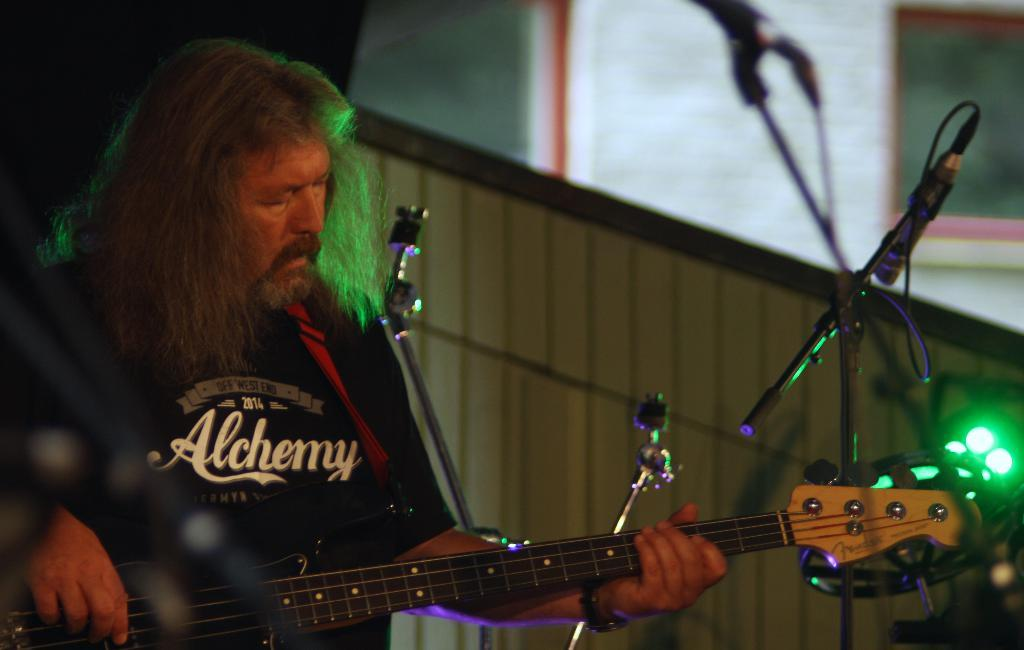What is the main subject of the image? There is a man in the image. What is the man holding in his left hand? The man is holding a guitar with his left hand. What is the man doing with his right hand? The man is playing the guitar with his right hand. What type of zinc is the man using to play the guitar in the image? There is no zinc present in the image; the man is playing a guitar with his hands. Is there a servant in the image assisting the man with the guitar? There is no servant present in the image; the man is playing the guitar by himself. 